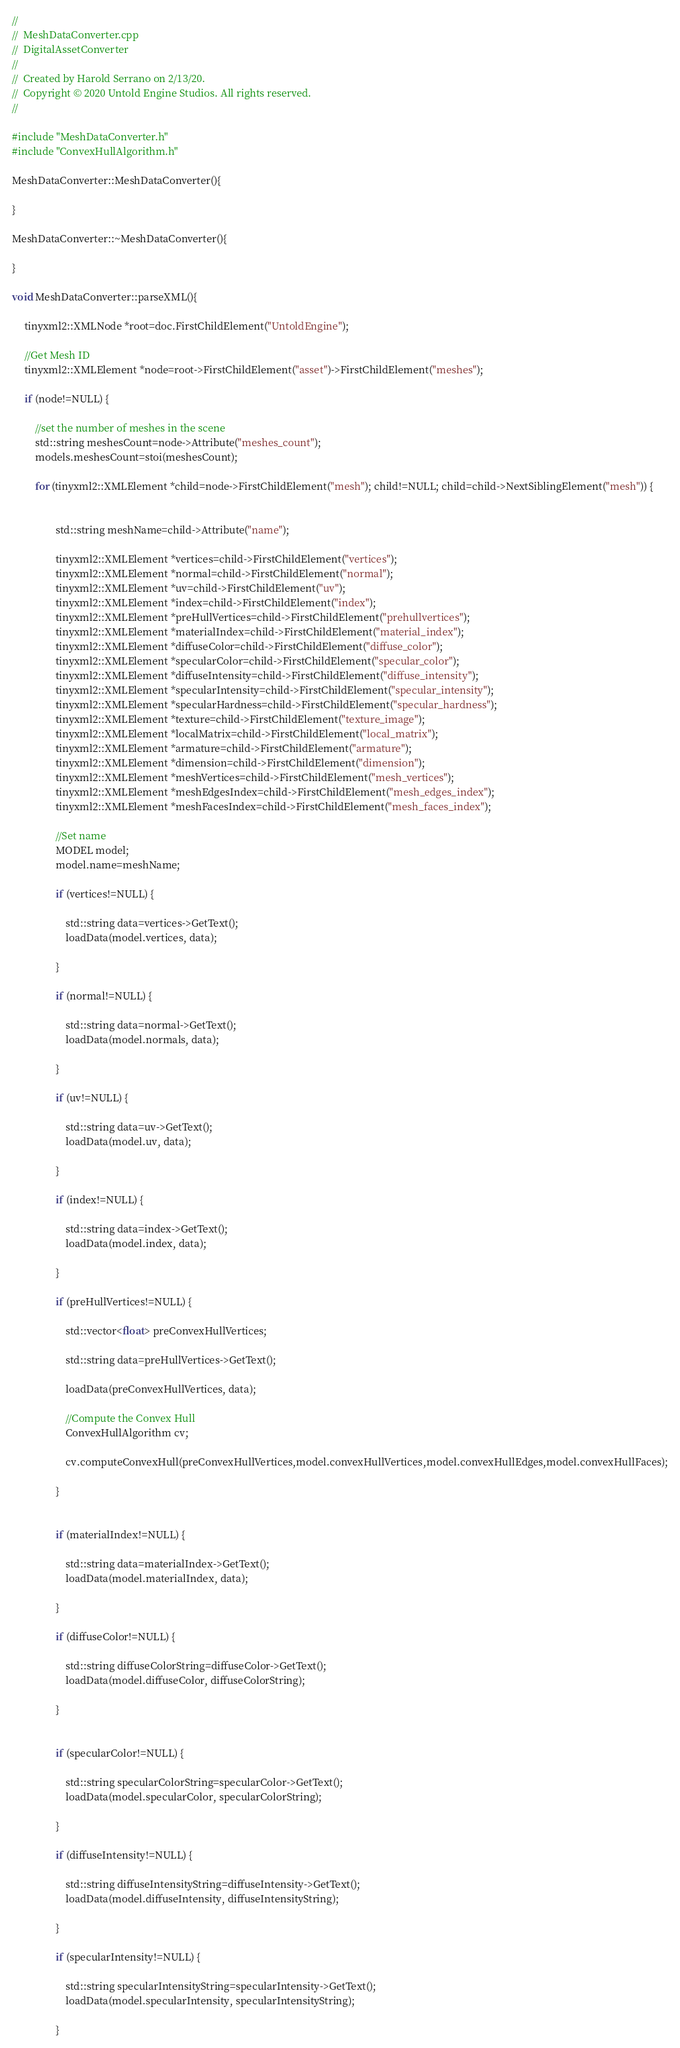<code> <loc_0><loc_0><loc_500><loc_500><_ObjectiveC_>//
//  MeshDataConverter.cpp
//  DigitalAssetConverter
//
//  Created by Harold Serrano on 2/13/20.
//  Copyright © 2020 Untold Engine Studios. All rights reserved.
//

#include "MeshDataConverter.h"
#include "ConvexHullAlgorithm.h"

MeshDataConverter::MeshDataConverter(){
    
}

MeshDataConverter::~MeshDataConverter(){
    
}

void MeshDataConverter::parseXML(){
     
     tinyxml2::XMLNode *root=doc.FirstChildElement("UntoldEngine");
     
     //Get Mesh ID
     tinyxml2::XMLElement *node=root->FirstChildElement("asset")->FirstChildElement("meshes");
     
     if (node!=NULL) {
         
         //set the number of meshes in the scene
         std::string meshesCount=node->Attribute("meshes_count");
         models.meshesCount=stoi(meshesCount);
         
         for (tinyxml2::XMLElement *child=node->FirstChildElement("mesh"); child!=NULL; child=child->NextSiblingElement("mesh")) {
             
             
                 std::string meshName=child->Attribute("name");
             
                 tinyxml2::XMLElement *vertices=child->FirstChildElement("vertices");
                 tinyxml2::XMLElement *normal=child->FirstChildElement("normal");
                 tinyxml2::XMLElement *uv=child->FirstChildElement("uv");
                 tinyxml2::XMLElement *index=child->FirstChildElement("index");
                 tinyxml2::XMLElement *preHullVertices=child->FirstChildElement("prehullvertices");
                 tinyxml2::XMLElement *materialIndex=child->FirstChildElement("material_index");
                 tinyxml2::XMLElement *diffuseColor=child->FirstChildElement("diffuse_color");
                 tinyxml2::XMLElement *specularColor=child->FirstChildElement("specular_color");
                 tinyxml2::XMLElement *diffuseIntensity=child->FirstChildElement("diffuse_intensity");
                 tinyxml2::XMLElement *specularIntensity=child->FirstChildElement("specular_intensity");
                 tinyxml2::XMLElement *specularHardness=child->FirstChildElement("specular_hardness");
                 tinyxml2::XMLElement *texture=child->FirstChildElement("texture_image");
                 tinyxml2::XMLElement *localMatrix=child->FirstChildElement("local_matrix");
                 tinyxml2::XMLElement *armature=child->FirstChildElement("armature");
                 tinyxml2::XMLElement *dimension=child->FirstChildElement("dimension");
                 tinyxml2::XMLElement *meshVertices=child->FirstChildElement("mesh_vertices");
                 tinyxml2::XMLElement *meshEdgesIndex=child->FirstChildElement("mesh_edges_index");
                 tinyxml2::XMLElement *meshFacesIndex=child->FirstChildElement("mesh_faces_index");
                 
                 //Set name
                 MODEL model;
                 model.name=meshName;

                 if (vertices!=NULL) {
                     
                     std::string data=vertices->GetText();
                     loadData(model.vertices, data);
                     
                 }
                 
                 if (normal!=NULL) {

                     std::string data=normal->GetText();
                     loadData(model.normals, data);

                 }

                 if (uv!=NULL) {

                     std::string data=uv->GetText();
                     loadData(model.uv, data);

                 }

                 if (index!=NULL) {

                     std::string data=index->GetText();
                     loadData(model.index, data);

                 }
                 
                 if (preHullVertices!=NULL) {
                     
                     std::vector<float> preConvexHullVertices;
                     
                     std::string data=preHullVertices->GetText();
                     
                     loadData(preConvexHullVertices, data);
                     
                     //Compute the Convex Hull
                     ConvexHullAlgorithm cv;
                     
                     cv.computeConvexHull(preConvexHullVertices,model.convexHullVertices,model.convexHullEdges,model.convexHullFaces);
                 
                 }
                 
                 
                 if (materialIndex!=NULL) {
                     
                     std::string data=materialIndex->GetText();
                     loadData(model.materialIndex, data);
                     
                 }
                 
                 if (diffuseColor!=NULL) {
                     
                     std::string diffuseColorString=diffuseColor->GetText();
                     loadData(model.diffuseColor, diffuseColorString);
                     
                 }
                 
                 
                 if (specularColor!=NULL) {
                     
                     std::string specularColorString=specularColor->GetText();
                     loadData(model.specularColor, specularColorString);
                     
                 }
                 
                 if (diffuseIntensity!=NULL) {
                     
                     std::string diffuseIntensityString=diffuseIntensity->GetText();
                     loadData(model.diffuseIntensity, diffuseIntensityString);
                     
                 }
                 
                 if (specularIntensity!=NULL) {
                     
                     std::string specularIntensityString=specularIntensity->GetText();
                     loadData(model.specularIntensity, specularIntensityString);
                     
                 }</code> 